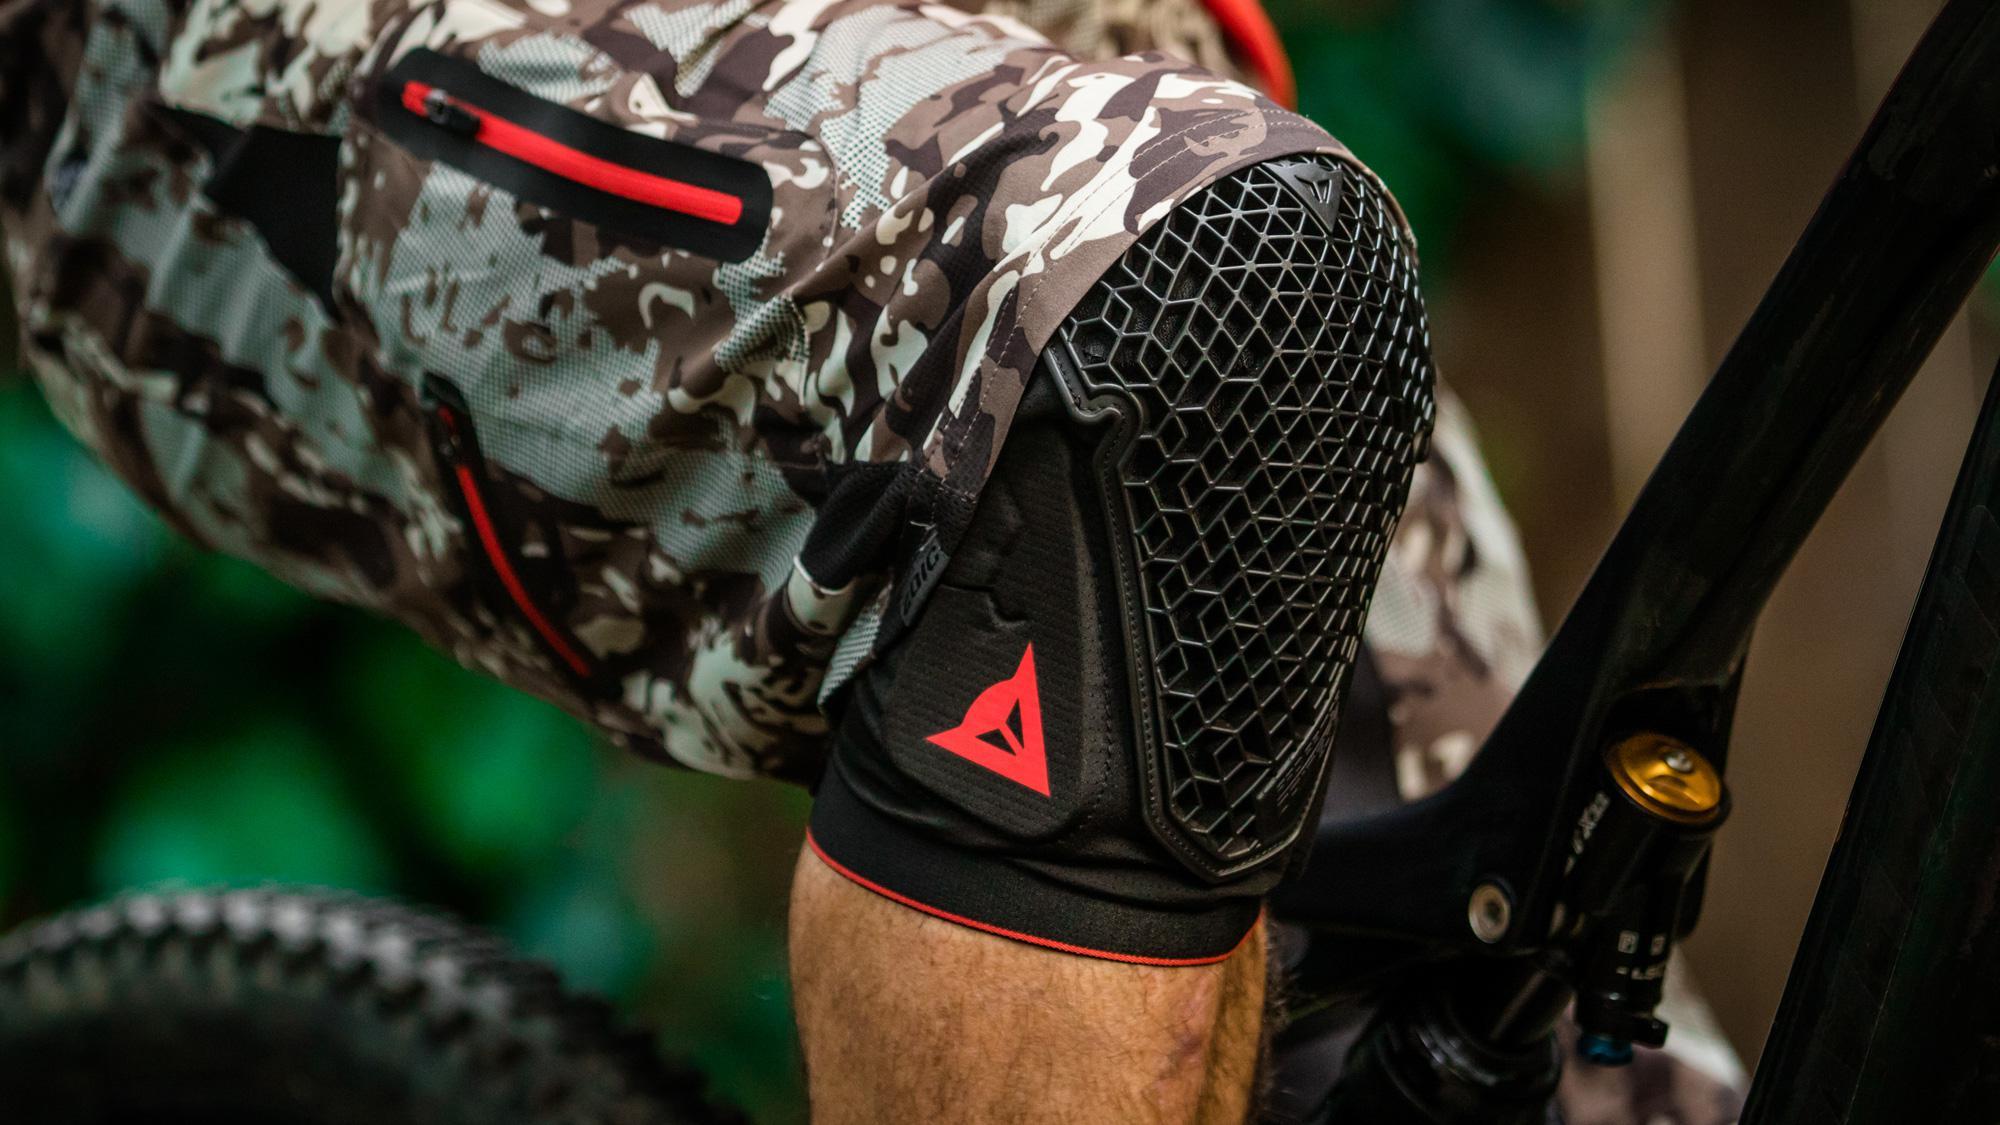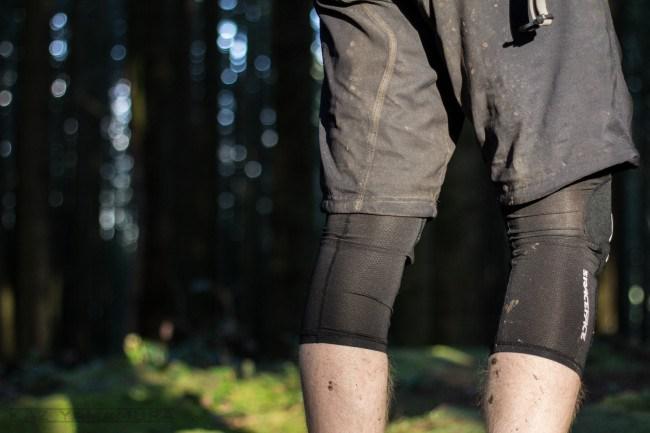The first image is the image on the left, the second image is the image on the right. Given the left and right images, does the statement "There is an elbow pad." hold true? Answer yes or no. No. The first image is the image on the left, the second image is the image on the right. Considering the images on both sides, is "Two legs in one image wear knee pads with a perforated front, and the other image shows a pad that is not on a person's knee." valid? Answer yes or no. No. 